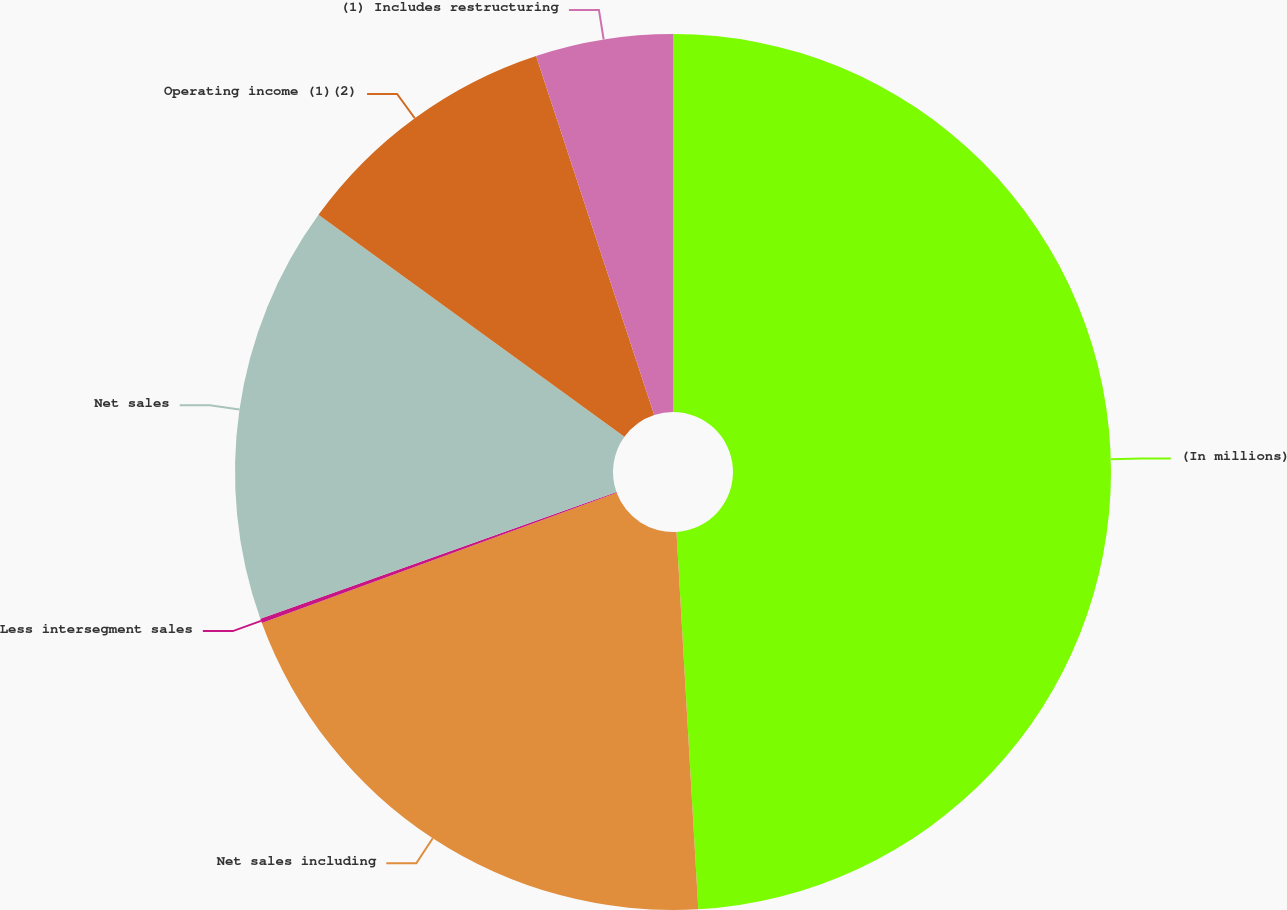<chart> <loc_0><loc_0><loc_500><loc_500><pie_chart><fcel>(In millions)<fcel>Net sales including<fcel>Less intersegment sales<fcel>Net sales<fcel>Operating income (1)(2)<fcel>(1) Includes restructuring<nl><fcel>49.08%<fcel>20.32%<fcel>0.16%<fcel>15.43%<fcel>9.95%<fcel>5.06%<nl></chart> 